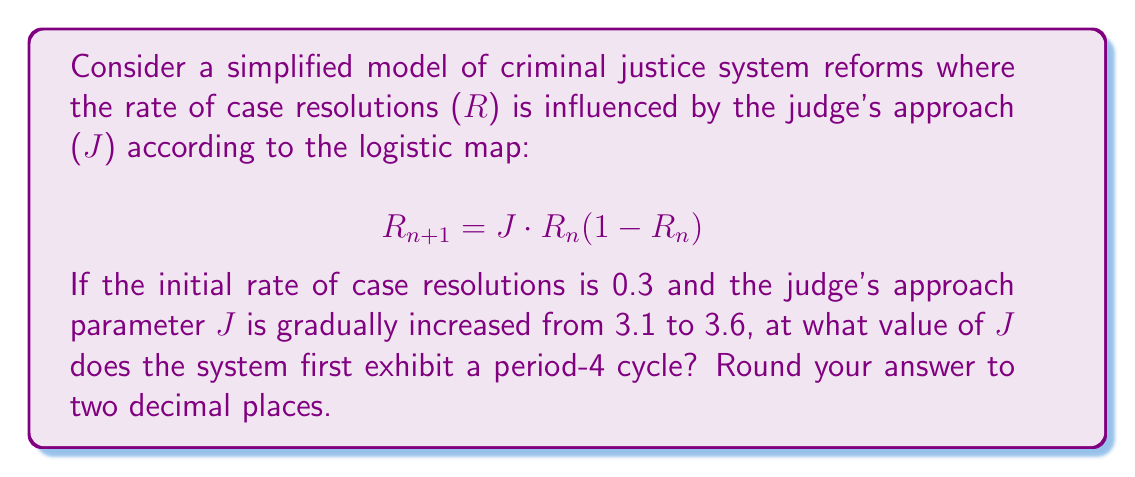Solve this math problem. To solve this problem, we need to understand period-doubling bifurcations in the logistic map and how they relate to the judge's approach parameter J:

1. Start with J = 3.1 and iterate the map several times to observe the long-term behavior:
   $$R_0 = 0.3$$
   $$R_1 = 3.1 \cdot 0.3(1-0.3) = 0.651$$
   $$R_2 = 3.1 \cdot 0.651(1-0.651) = 0.7034$$
   ...
   The system converges to a single fixed point.

2. Gradually increase J and observe the behavior:
   - At J ≈ 3.45, the system transitions from a single fixed point to a period-2 cycle.
   - As J increases further, the period-2 cycle becomes unstable and transitions to a period-4 cycle.

3. To find the exact J value for the period-4 cycle, we need to use the properties of the logistic map:
   - The first period-doubling (1 to 2) occurs at J = 3
   - The second period-doubling (2 to 4) occurs at J = 1 + √6 ≈ 3.4495

4. Therefore, the system first exhibits a period-4 cycle when J ≈ 3.45 (rounded to two decimal places).

5. To verify, we can iterate the map with J = 3.45:
   $$R_0 = 0.3$$
   $$R_1 = 3.45 \cdot 0.3(1-0.3) = 0.7245$$
   $$R_2 = 3.45 \cdot 0.7245(1-0.7245) = 0.8890$$
   $$R_3 = 3.45 \cdot 0.8890(1-0.8890) = 0.3399$$
   $$R_4 = 3.45 \cdot 0.3399(1-0.3399) = 0.7729$$
   ...
   The system cycles through 4 distinct values, confirming the period-4 behavior.
Answer: 3.45 